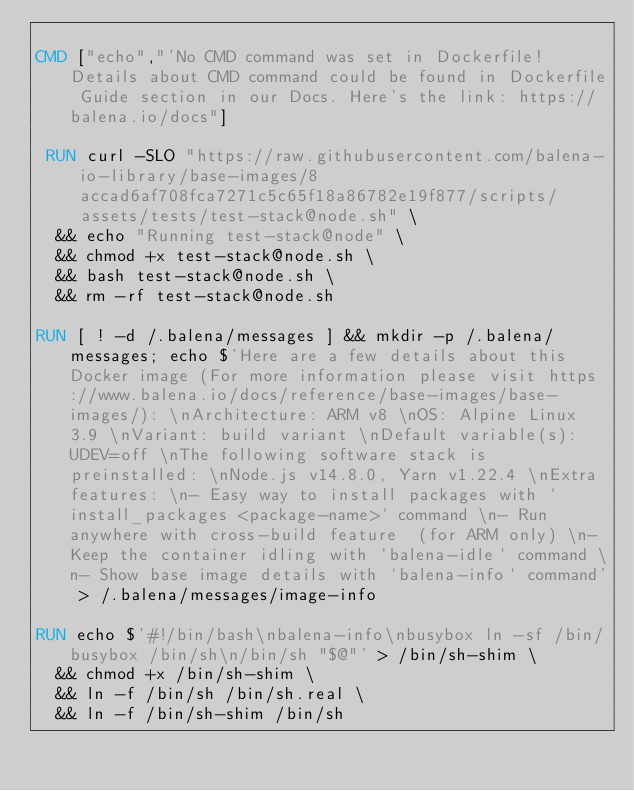<code> <loc_0><loc_0><loc_500><loc_500><_Dockerfile_>
CMD ["echo","'No CMD command was set in Dockerfile! Details about CMD command could be found in Dockerfile Guide section in our Docs. Here's the link: https://balena.io/docs"]

 RUN curl -SLO "https://raw.githubusercontent.com/balena-io-library/base-images/8accad6af708fca7271c5c65f18a86782e19f877/scripts/assets/tests/test-stack@node.sh" \
  && echo "Running test-stack@node" \
  && chmod +x test-stack@node.sh \
  && bash test-stack@node.sh \
  && rm -rf test-stack@node.sh 

RUN [ ! -d /.balena/messages ] && mkdir -p /.balena/messages; echo $'Here are a few details about this Docker image (For more information please visit https://www.balena.io/docs/reference/base-images/base-images/): \nArchitecture: ARM v8 \nOS: Alpine Linux 3.9 \nVariant: build variant \nDefault variable(s): UDEV=off \nThe following software stack is preinstalled: \nNode.js v14.8.0, Yarn v1.22.4 \nExtra features: \n- Easy way to install packages with `install_packages <package-name>` command \n- Run anywhere with cross-build feature  (for ARM only) \n- Keep the container idling with `balena-idle` command \n- Show base image details with `balena-info` command' > /.balena/messages/image-info

RUN echo $'#!/bin/bash\nbalena-info\nbusybox ln -sf /bin/busybox /bin/sh\n/bin/sh "$@"' > /bin/sh-shim \
	&& chmod +x /bin/sh-shim \
	&& ln -f /bin/sh /bin/sh.real \
	&& ln -f /bin/sh-shim /bin/sh</code> 